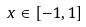<formula> <loc_0><loc_0><loc_500><loc_500>x \in [ - 1 , 1 ]</formula> 